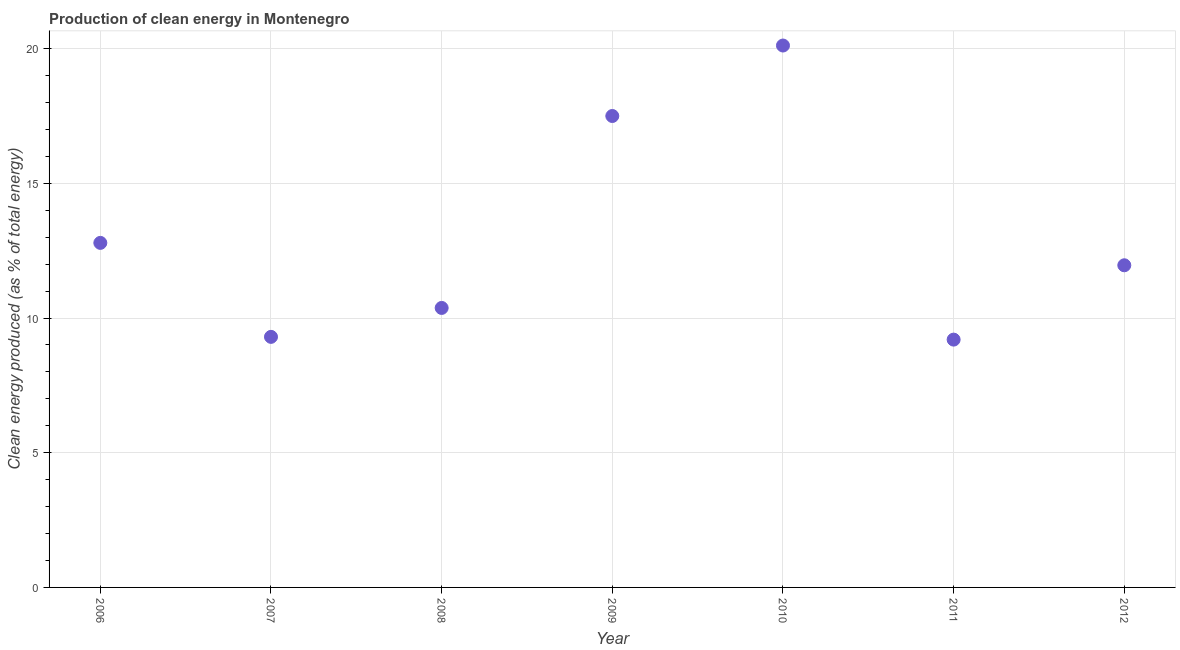What is the production of clean energy in 2007?
Give a very brief answer. 9.3. Across all years, what is the maximum production of clean energy?
Give a very brief answer. 20.11. Across all years, what is the minimum production of clean energy?
Provide a short and direct response. 9.2. What is the sum of the production of clean energy?
Provide a succinct answer. 91.23. What is the difference between the production of clean energy in 2006 and 2009?
Offer a terse response. -4.71. What is the average production of clean energy per year?
Your answer should be very brief. 13.03. What is the median production of clean energy?
Provide a short and direct response. 11.96. In how many years, is the production of clean energy greater than 10 %?
Offer a very short reply. 5. What is the ratio of the production of clean energy in 2006 to that in 2011?
Offer a very short reply. 1.39. Is the difference between the production of clean energy in 2008 and 2009 greater than the difference between any two years?
Make the answer very short. No. What is the difference between the highest and the second highest production of clean energy?
Give a very brief answer. 2.62. What is the difference between the highest and the lowest production of clean energy?
Offer a terse response. 10.92. In how many years, is the production of clean energy greater than the average production of clean energy taken over all years?
Your answer should be compact. 2. How many dotlines are there?
Ensure brevity in your answer.  1. How many years are there in the graph?
Keep it short and to the point. 7. What is the title of the graph?
Offer a terse response. Production of clean energy in Montenegro. What is the label or title of the X-axis?
Your answer should be compact. Year. What is the label or title of the Y-axis?
Make the answer very short. Clean energy produced (as % of total energy). What is the Clean energy produced (as % of total energy) in 2006?
Your answer should be very brief. 12.79. What is the Clean energy produced (as % of total energy) in 2007?
Provide a succinct answer. 9.3. What is the Clean energy produced (as % of total energy) in 2008?
Make the answer very short. 10.37. What is the Clean energy produced (as % of total energy) in 2009?
Your response must be concise. 17.5. What is the Clean energy produced (as % of total energy) in 2010?
Your response must be concise. 20.11. What is the Clean energy produced (as % of total energy) in 2011?
Offer a very short reply. 9.2. What is the Clean energy produced (as % of total energy) in 2012?
Make the answer very short. 11.96. What is the difference between the Clean energy produced (as % of total energy) in 2006 and 2007?
Provide a short and direct response. 3.49. What is the difference between the Clean energy produced (as % of total energy) in 2006 and 2008?
Keep it short and to the point. 2.41. What is the difference between the Clean energy produced (as % of total energy) in 2006 and 2009?
Offer a terse response. -4.71. What is the difference between the Clean energy produced (as % of total energy) in 2006 and 2010?
Keep it short and to the point. -7.33. What is the difference between the Clean energy produced (as % of total energy) in 2006 and 2011?
Make the answer very short. 3.59. What is the difference between the Clean energy produced (as % of total energy) in 2006 and 2012?
Offer a terse response. 0.83. What is the difference between the Clean energy produced (as % of total energy) in 2007 and 2008?
Provide a short and direct response. -1.07. What is the difference between the Clean energy produced (as % of total energy) in 2007 and 2009?
Provide a succinct answer. -8.2. What is the difference between the Clean energy produced (as % of total energy) in 2007 and 2010?
Provide a short and direct response. -10.81. What is the difference between the Clean energy produced (as % of total energy) in 2007 and 2011?
Your answer should be compact. 0.1. What is the difference between the Clean energy produced (as % of total energy) in 2007 and 2012?
Offer a very short reply. -2.66. What is the difference between the Clean energy produced (as % of total energy) in 2008 and 2009?
Give a very brief answer. -7.12. What is the difference between the Clean energy produced (as % of total energy) in 2008 and 2010?
Offer a terse response. -9.74. What is the difference between the Clean energy produced (as % of total energy) in 2008 and 2011?
Keep it short and to the point. 1.18. What is the difference between the Clean energy produced (as % of total energy) in 2008 and 2012?
Your answer should be compact. -1.58. What is the difference between the Clean energy produced (as % of total energy) in 2009 and 2010?
Ensure brevity in your answer.  -2.62. What is the difference between the Clean energy produced (as % of total energy) in 2009 and 2011?
Make the answer very short. 8.3. What is the difference between the Clean energy produced (as % of total energy) in 2009 and 2012?
Offer a very short reply. 5.54. What is the difference between the Clean energy produced (as % of total energy) in 2010 and 2011?
Provide a short and direct response. 10.92. What is the difference between the Clean energy produced (as % of total energy) in 2010 and 2012?
Keep it short and to the point. 8.16. What is the difference between the Clean energy produced (as % of total energy) in 2011 and 2012?
Offer a very short reply. -2.76. What is the ratio of the Clean energy produced (as % of total energy) in 2006 to that in 2007?
Offer a very short reply. 1.38. What is the ratio of the Clean energy produced (as % of total energy) in 2006 to that in 2008?
Provide a succinct answer. 1.23. What is the ratio of the Clean energy produced (as % of total energy) in 2006 to that in 2009?
Provide a short and direct response. 0.73. What is the ratio of the Clean energy produced (as % of total energy) in 2006 to that in 2010?
Your response must be concise. 0.64. What is the ratio of the Clean energy produced (as % of total energy) in 2006 to that in 2011?
Offer a very short reply. 1.39. What is the ratio of the Clean energy produced (as % of total energy) in 2006 to that in 2012?
Make the answer very short. 1.07. What is the ratio of the Clean energy produced (as % of total energy) in 2007 to that in 2008?
Offer a terse response. 0.9. What is the ratio of the Clean energy produced (as % of total energy) in 2007 to that in 2009?
Keep it short and to the point. 0.53. What is the ratio of the Clean energy produced (as % of total energy) in 2007 to that in 2010?
Your response must be concise. 0.46. What is the ratio of the Clean energy produced (as % of total energy) in 2007 to that in 2011?
Offer a terse response. 1.01. What is the ratio of the Clean energy produced (as % of total energy) in 2007 to that in 2012?
Offer a terse response. 0.78. What is the ratio of the Clean energy produced (as % of total energy) in 2008 to that in 2009?
Your answer should be compact. 0.59. What is the ratio of the Clean energy produced (as % of total energy) in 2008 to that in 2010?
Keep it short and to the point. 0.52. What is the ratio of the Clean energy produced (as % of total energy) in 2008 to that in 2011?
Provide a succinct answer. 1.13. What is the ratio of the Clean energy produced (as % of total energy) in 2008 to that in 2012?
Give a very brief answer. 0.87. What is the ratio of the Clean energy produced (as % of total energy) in 2009 to that in 2010?
Your response must be concise. 0.87. What is the ratio of the Clean energy produced (as % of total energy) in 2009 to that in 2011?
Make the answer very short. 1.9. What is the ratio of the Clean energy produced (as % of total energy) in 2009 to that in 2012?
Provide a succinct answer. 1.46. What is the ratio of the Clean energy produced (as % of total energy) in 2010 to that in 2011?
Your response must be concise. 2.19. What is the ratio of the Clean energy produced (as % of total energy) in 2010 to that in 2012?
Offer a very short reply. 1.68. What is the ratio of the Clean energy produced (as % of total energy) in 2011 to that in 2012?
Keep it short and to the point. 0.77. 